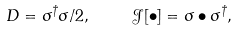<formula> <loc_0><loc_0><loc_500><loc_500>D = \sigma ^ { \dagger } \sigma / 2 , \quad \ \mathcal { J } [ \bullet ] = \sigma \bullet \sigma ^ { \dagger } ,</formula> 